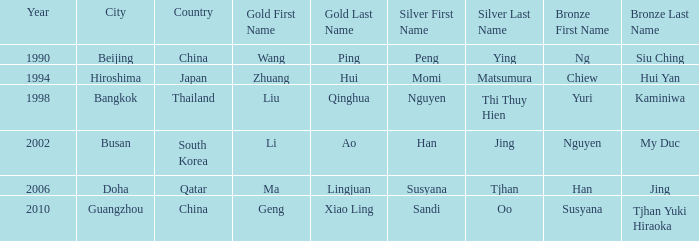What Silver has the Location of Guangzhou? Sandi Oo. 